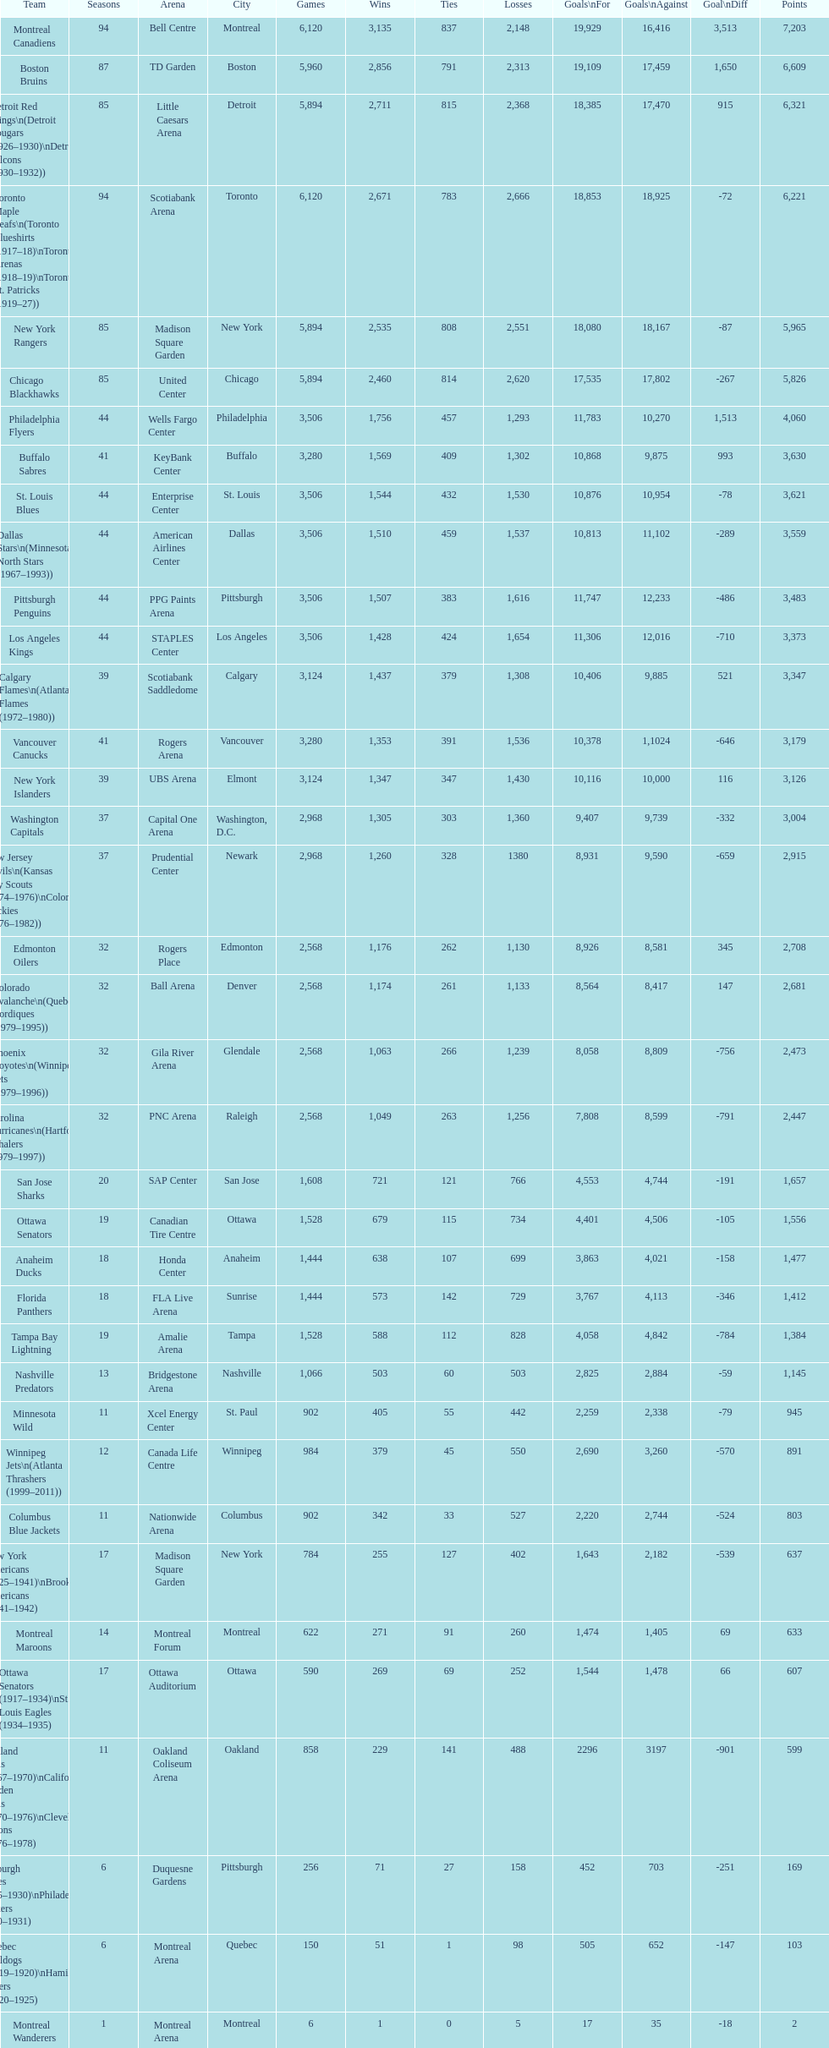How many losses do the st. louis blues have? 1,530. 